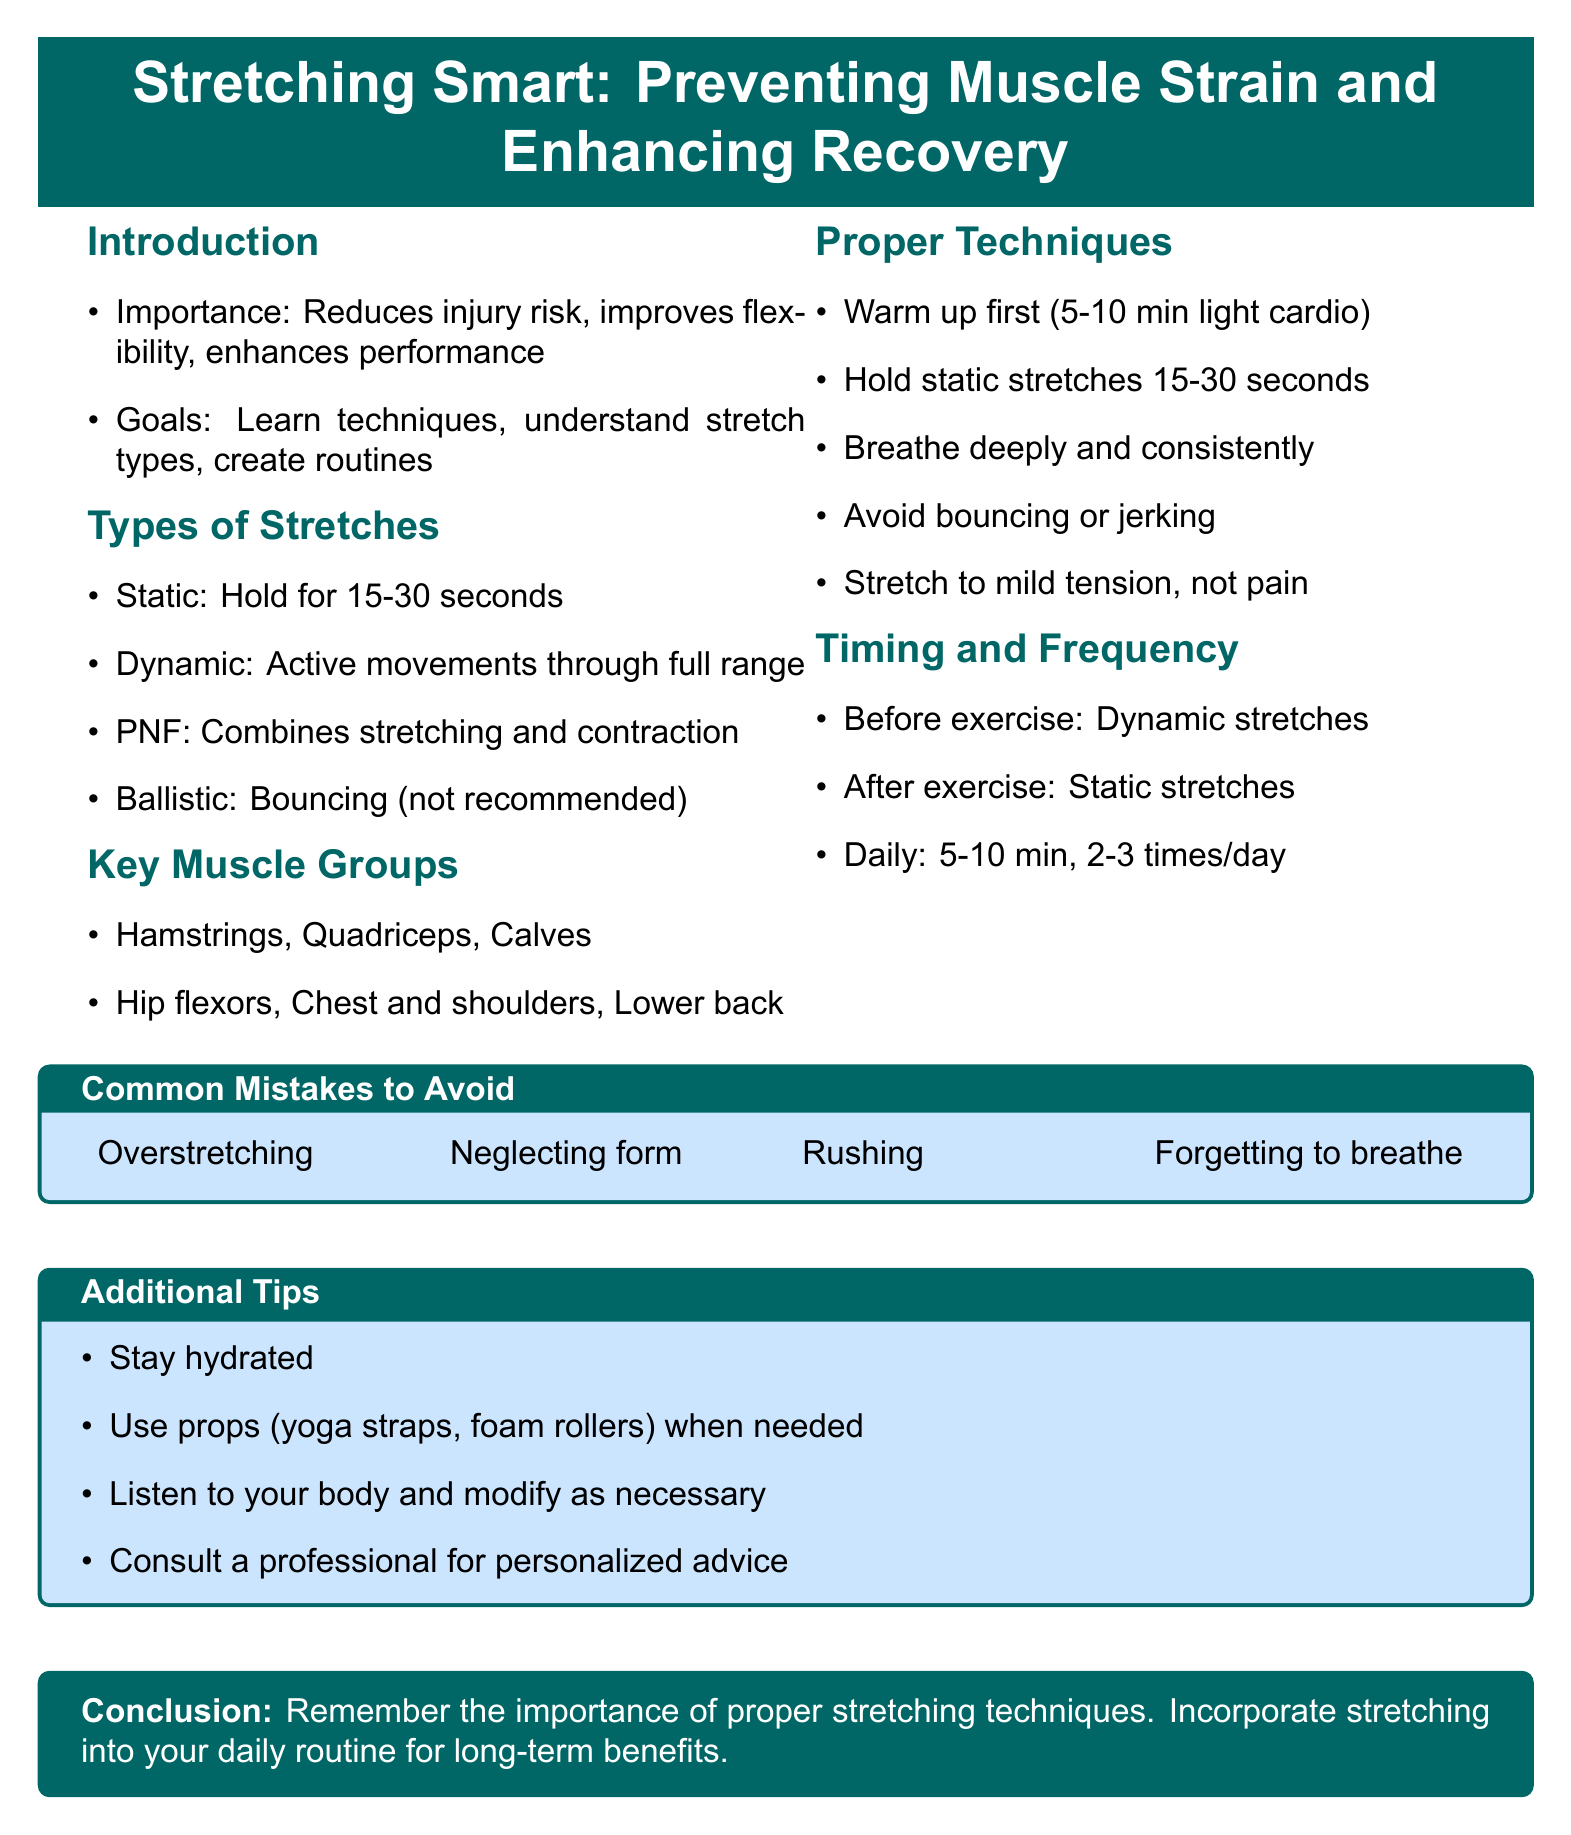What is the workshop title? The workshop title is explicitly stated at the beginning of the document.
Answer: Stretching Smart: Preventing Muscle Strain and Enhancing Recovery What are dynamic stretches focused on? The document specifies that dynamic stretches should be performed before exercising.
Answer: Active movements through full range of motion How long should static stretches be held? The document clearly states the duration for holding static stretches.
Answer: 15-30 seconds What should be incorporated into a daily routine? The conclusion emphasizes the importance of a specific activity related to health.
Answer: Stretching What is a common mistake to avoid during stretching? The document lists several common mistakes to avoid while stretching.
Answer: Overstretching What muscle group is mentioned as a key area to focus on? The document lists several key muscle groups, providing specific examples.
Answer: Hamstrings How often should you aim to stretch in a daily routine? The document outlines a specific frequency for stretching in a day.
Answer: 2-3 times per day What technique should be used to help avoid pain while stretching? The document advises on a specific approach to ensure stretching is safe.
Answer: Stretch to the point of mild tension, not pain What additional tip is provided for improving stretching routines? The document suggests using resources to enhance the stretching experience.
Answer: Use props like yoga straps or foam rollers when needed 